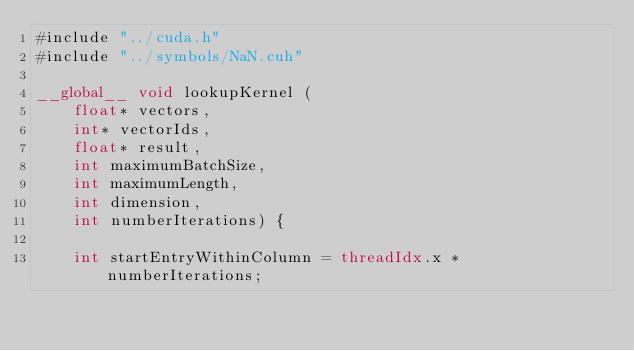<code> <loc_0><loc_0><loc_500><loc_500><_Cuda_>#include "../cuda.h"
#include "../symbols/NaN.cuh"

__global__ void lookupKernel (
    float* vectors,
    int* vectorIds,
    float* result,
    int maximumBatchSize,
    int maximumLength,
    int dimension,
    int numberIterations) {

    int startEntryWithinColumn = threadIdx.x * numberIterations;
</code> 